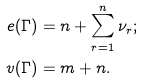Convert formula to latex. <formula><loc_0><loc_0><loc_500><loc_500>e ( \Gamma ) & = n + \sum _ { r = 1 } ^ { n } \nu _ { r } ; \\ v ( \Gamma ) & = m + n .</formula> 